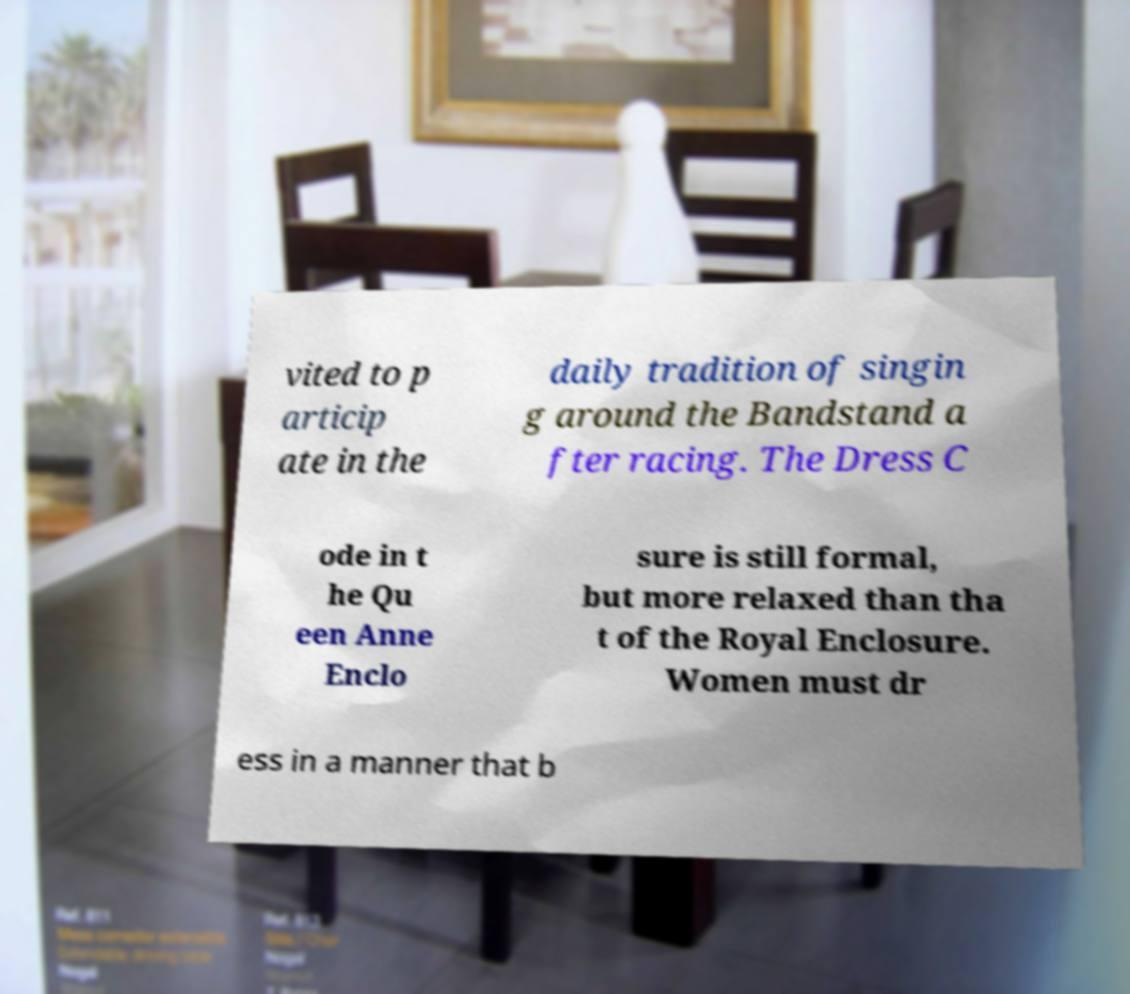Could you extract and type out the text from this image? vited to p articip ate in the daily tradition of singin g around the Bandstand a fter racing. The Dress C ode in t he Qu een Anne Enclo sure is still formal, but more relaxed than tha t of the Royal Enclosure. Women must dr ess in a manner that b 